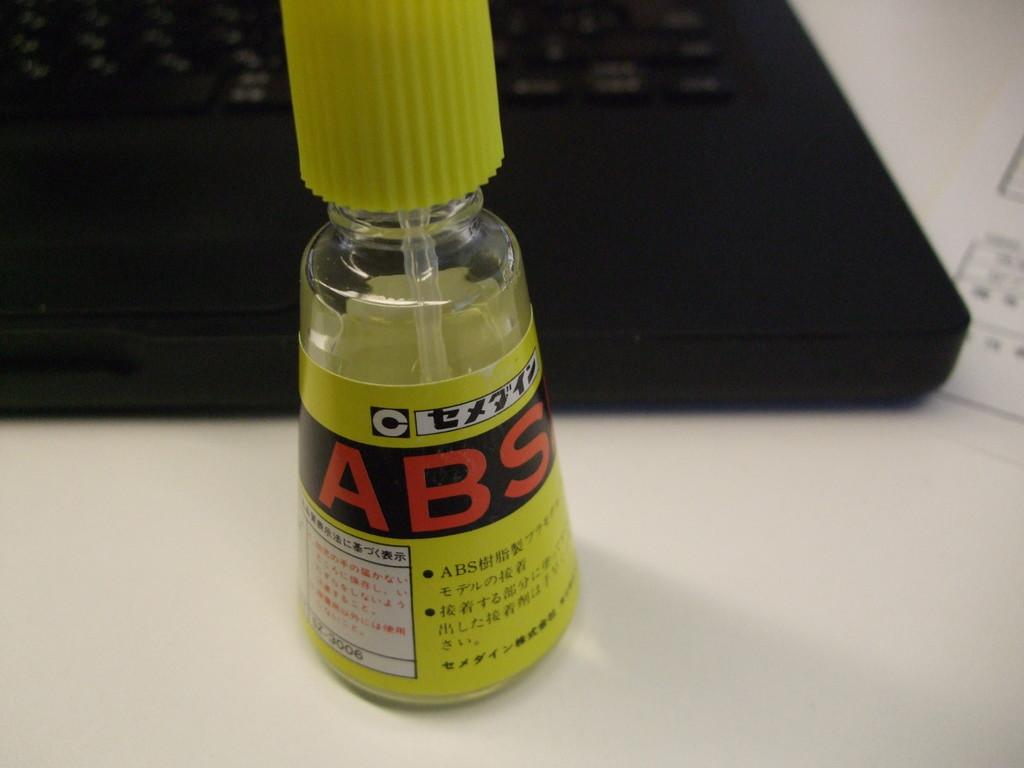Provide a one-sentence caption for the provided image. A yellow bottle with a brush in it and the letters ABS visible on the side in red. 